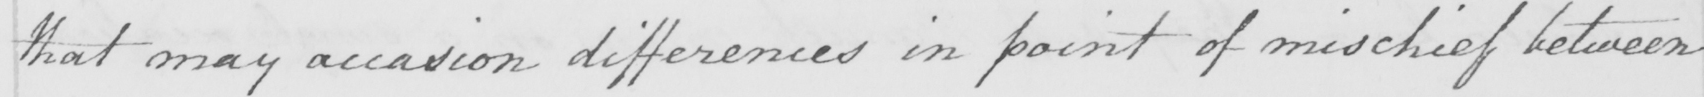Can you read and transcribe this handwriting? that may accasion differences in point of mischief between 